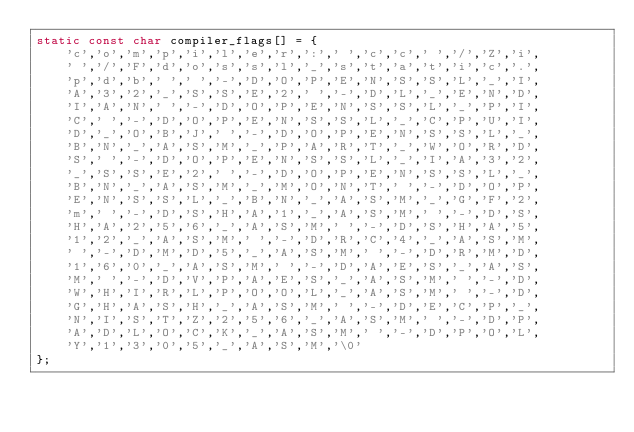<code> <loc_0><loc_0><loc_500><loc_500><_C_>static const char compiler_flags[] = {
    'c','o','m','p','i','l','e','r',':',' ','c','c',' ','/','Z','i',
    ' ','/','F','d','o','s','s','l','_','s','t','a','t','i','c','.',
    'p','d','b',' ',' ','-','D','O','P','E','N','S','S','L','_','I',
    'A','3','2','_','S','S','E','2',' ','-','D','L','_','E','N','D',
    'I','A','N',' ','-','D','O','P','E','N','S','S','L','_','P','I',
    'C',' ','-','D','O','P','E','N','S','S','L','_','C','P','U','I',
    'D','_','O','B','J',' ','-','D','O','P','E','N','S','S','L','_',
    'B','N','_','A','S','M','_','P','A','R','T','_','W','O','R','D',
    'S',' ','-','D','O','P','E','N','S','S','L','_','I','A','3','2',
    '_','S','S','E','2',' ','-','D','O','P','E','N','S','S','L','_',
    'B','N','_','A','S','M','_','M','O','N','T',' ','-','D','O','P',
    'E','N','S','S','L','_','B','N','_','A','S','M','_','G','F','2',
    'm',' ','-','D','S','H','A','1','_','A','S','M',' ','-','D','S',
    'H','A','2','5','6','_','A','S','M',' ','-','D','S','H','A','5',
    '1','2','_','A','S','M',' ','-','D','R','C','4','_','A','S','M',
    ' ','-','D','M','D','5','_','A','S','M',' ','-','D','R','M','D',
    '1','6','0','_','A','S','M',' ','-','D','A','E','S','_','A','S',
    'M',' ','-','D','V','P','A','E','S','_','A','S','M',' ','-','D',
    'W','H','I','R','L','P','O','O','L','_','A','S','M',' ','-','D',
    'G','H','A','S','H','_','A','S','M',' ','-','D','E','C','P','_',
    'N','I','S','T','Z','2','5','6','_','A','S','M',' ','-','D','P',
    'A','D','L','O','C','K','_','A','S','M',' ','-','D','P','O','L',
    'Y','1','3','0','5','_','A','S','M','\0'
};
</code> 